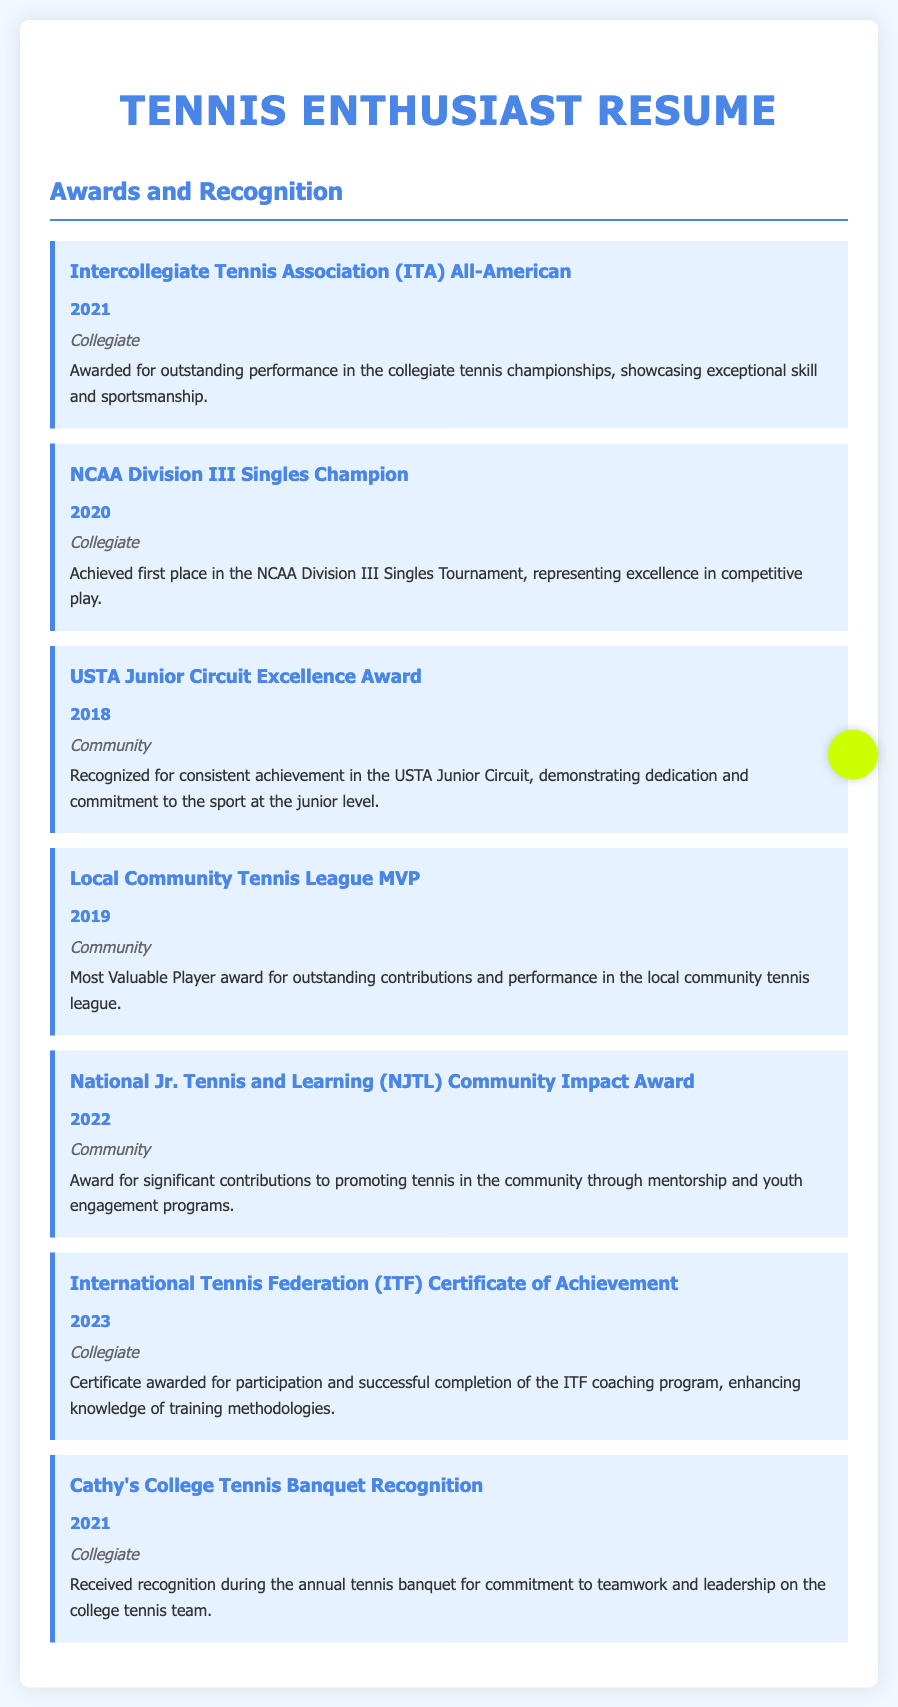What is the highest award received in collegiate tennis? The highest award mentioned in the collegiate section is the NCAA Division III Singles Champion, which was achieved in 2020.
Answer: NCAA Division III Singles Champion In what year was the ITA All-American awarded? The ITA All-American award was received in 2021.
Answer: 2021 What is the title of the award received for community impact? The title of the award for community impact is the National Jr. Tennis and Learning (NJTL) Community Impact Award.
Answer: National Jr. Tennis and Learning (NJTL) Community Impact Award How many awards are listed for collegiate recognition? There are four awards listed under collegiate recognition.
Answer: 4 Which award was given for achievement in the USTA Junior Circuit? The award for achievement in the USTA Junior Circuit is the USTA Junior Circuit Excellence Award received in 2018.
Answer: USTA Junior Circuit Excellence Award What sport is primarily focused on in the resume? The primary sport focused on in the resume is tennis.
Answer: Tennis What recognition was received in 2021 during a college banquet? The recognition received in 2021 at the college banquet was for commitment to teamwork and leadership.
Answer: Commitment to teamwork and leadership What level is the Local Community Tennis League MVP award classified under? The Local Community Tennis League MVP award is classified under the community level.
Answer: Community 